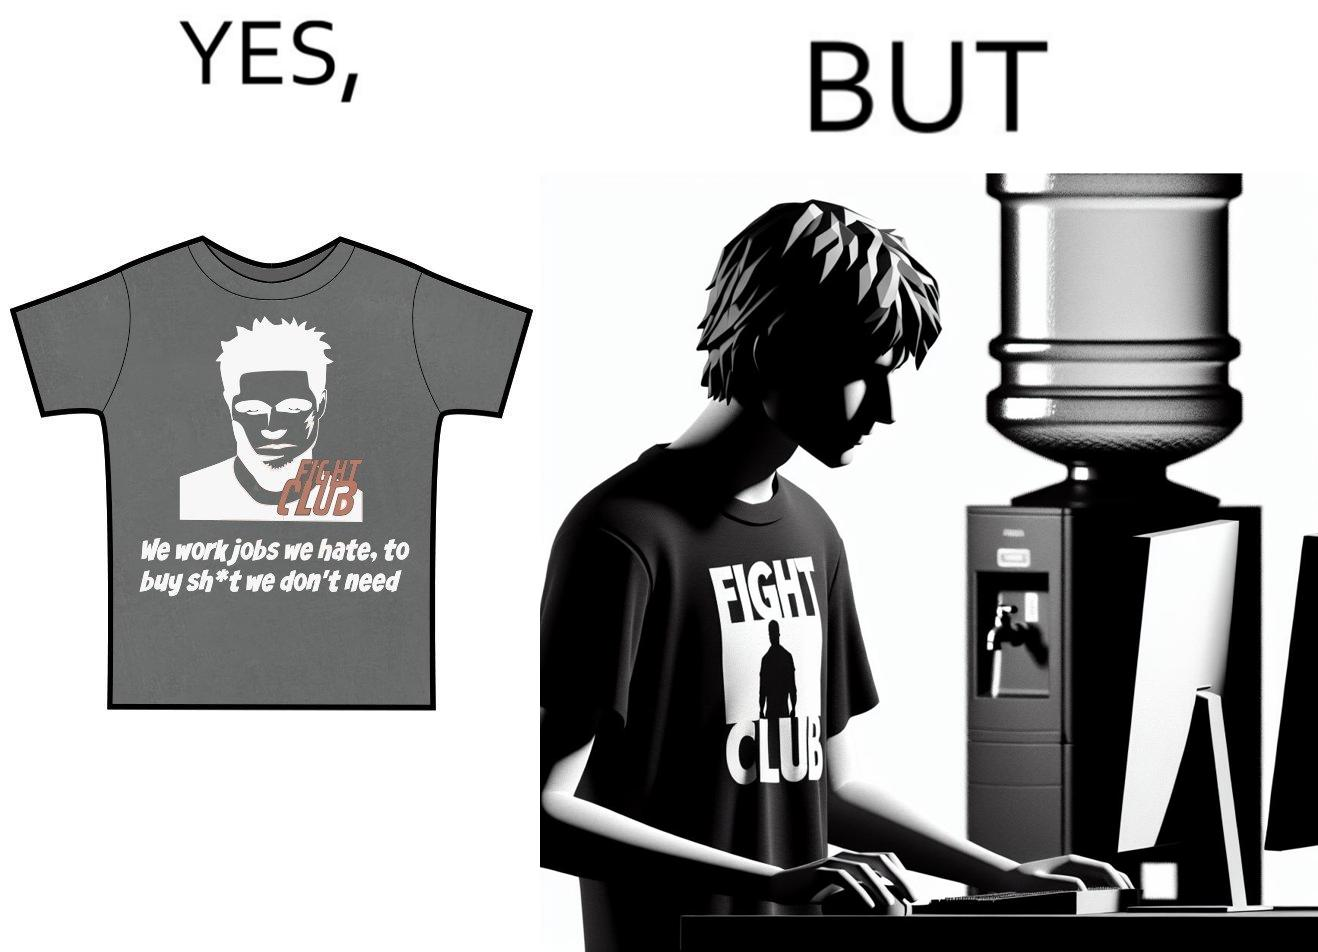Describe the satirical element in this image. The image is ironical, as the t-shirt says "We work jobs we hate, to buy sh*t we don't need", which is a rebellious message against the construct of office jobs. However, the person wearing the t-shirt seems to be working in an office environment. Also, the t-shirt might have been bought using the money earned via the very same job. 